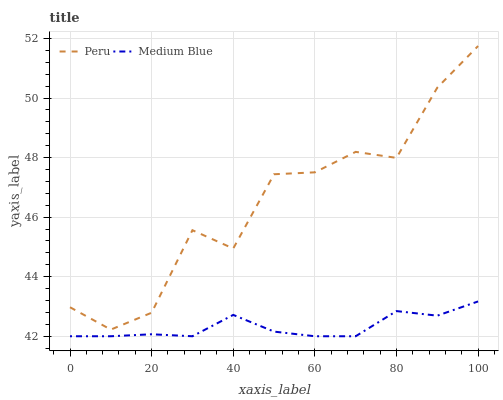Does Peru have the minimum area under the curve?
Answer yes or no. No. Is Peru the smoothest?
Answer yes or no. No. Does Peru have the lowest value?
Answer yes or no. No. Is Medium Blue less than Peru?
Answer yes or no. Yes. Is Peru greater than Medium Blue?
Answer yes or no. Yes. Does Medium Blue intersect Peru?
Answer yes or no. No. 